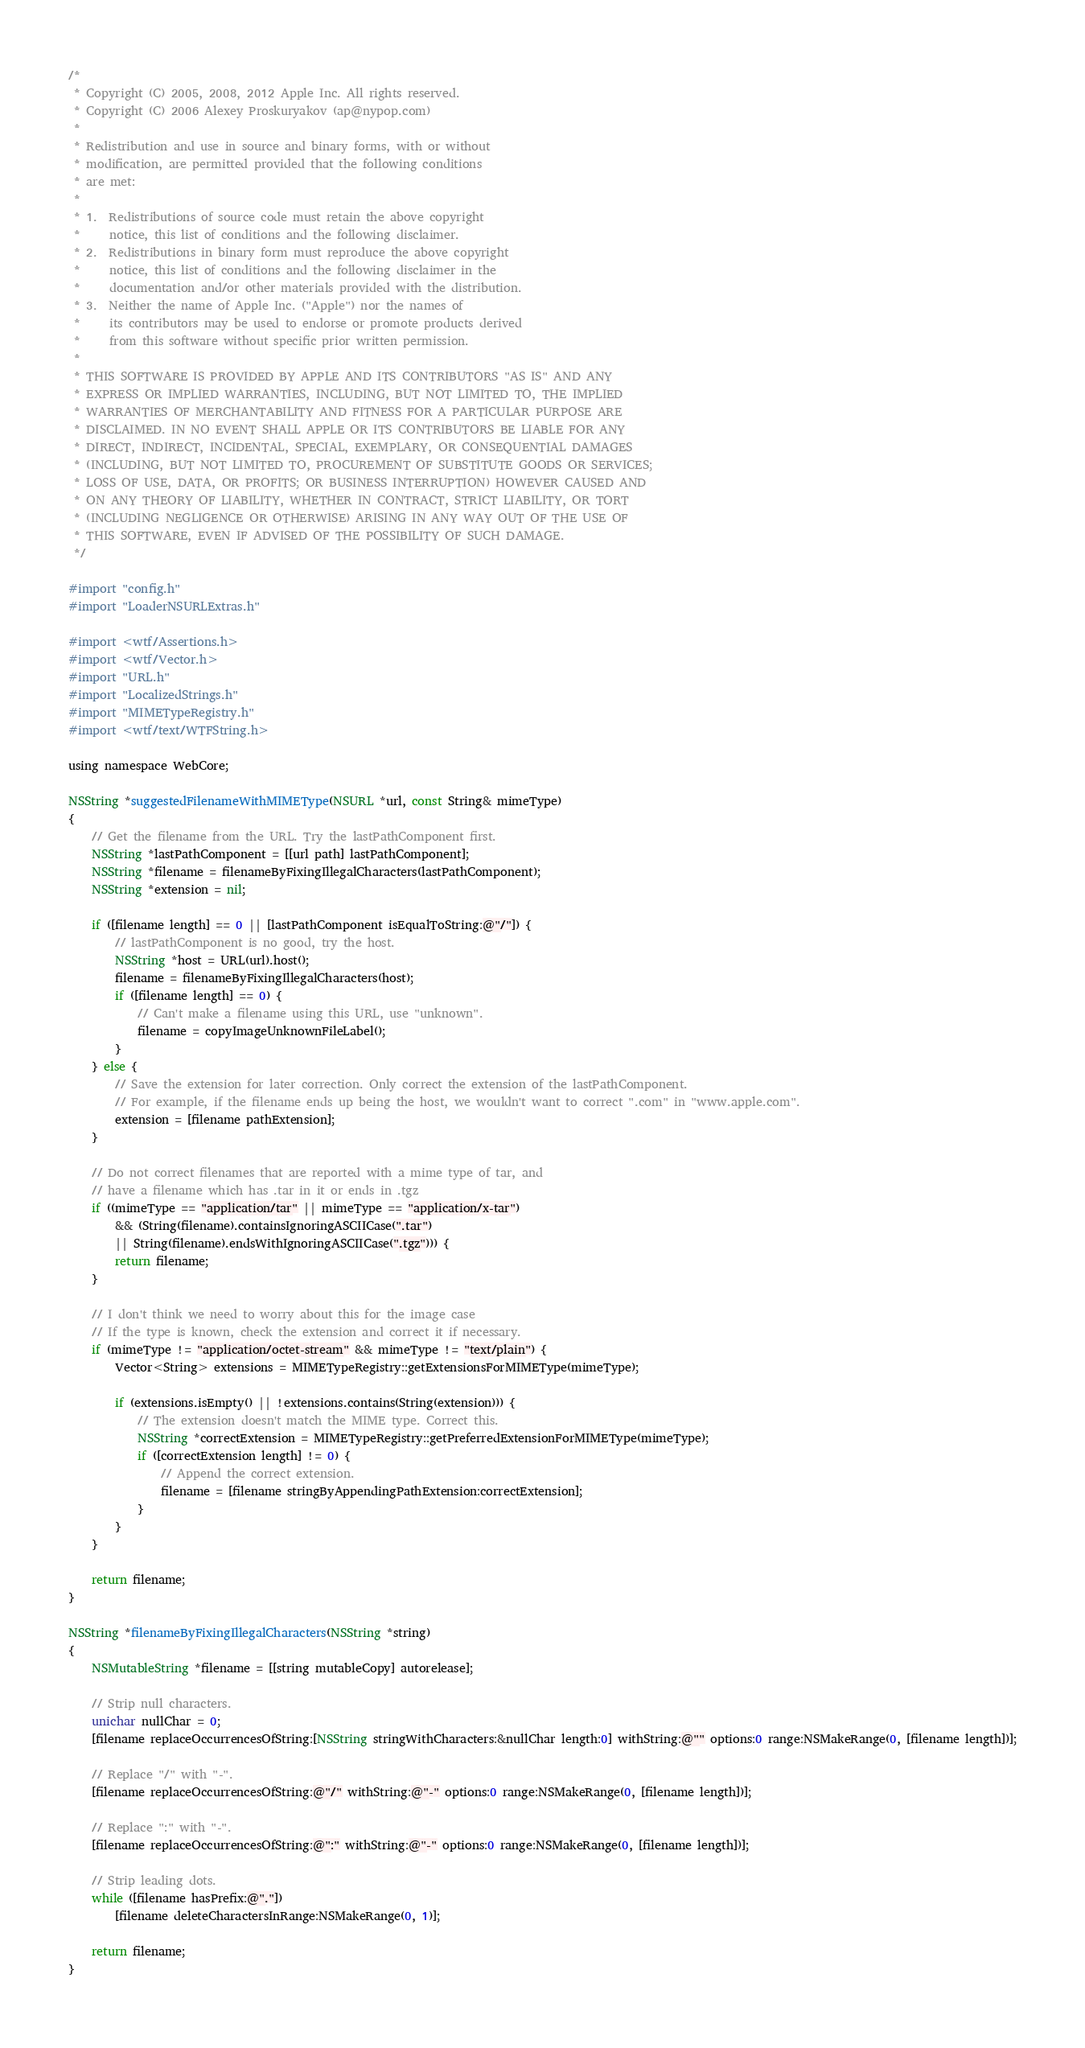Convert code to text. <code><loc_0><loc_0><loc_500><loc_500><_ObjectiveC_>/*
 * Copyright (C) 2005, 2008, 2012 Apple Inc. All rights reserved.
 * Copyright (C) 2006 Alexey Proskuryakov (ap@nypop.com)
 *
 * Redistribution and use in source and binary forms, with or without
 * modification, are permitted provided that the following conditions
 * are met:
 *
 * 1.  Redistributions of source code must retain the above copyright
 *     notice, this list of conditions and the following disclaimer. 
 * 2.  Redistributions in binary form must reproduce the above copyright
 *     notice, this list of conditions and the following disclaimer in the
 *     documentation and/or other materials provided with the distribution. 
 * 3.  Neither the name of Apple Inc. ("Apple") nor the names of
 *     its contributors may be used to endorse or promote products derived
 *     from this software without specific prior written permission. 
 *
 * THIS SOFTWARE IS PROVIDED BY APPLE AND ITS CONTRIBUTORS "AS IS" AND ANY
 * EXPRESS OR IMPLIED WARRANTIES, INCLUDING, BUT NOT LIMITED TO, THE IMPLIED
 * WARRANTIES OF MERCHANTABILITY AND FITNESS FOR A PARTICULAR PURPOSE ARE
 * DISCLAIMED. IN NO EVENT SHALL APPLE OR ITS CONTRIBUTORS BE LIABLE FOR ANY
 * DIRECT, INDIRECT, INCIDENTAL, SPECIAL, EXEMPLARY, OR CONSEQUENTIAL DAMAGES
 * (INCLUDING, BUT NOT LIMITED TO, PROCUREMENT OF SUBSTITUTE GOODS OR SERVICES;
 * LOSS OF USE, DATA, OR PROFITS; OR BUSINESS INTERRUPTION) HOWEVER CAUSED AND
 * ON ANY THEORY OF LIABILITY, WHETHER IN CONTRACT, STRICT LIABILITY, OR TORT
 * (INCLUDING NEGLIGENCE OR OTHERWISE) ARISING IN ANY WAY OUT OF THE USE OF
 * THIS SOFTWARE, EVEN IF ADVISED OF THE POSSIBILITY OF SUCH DAMAGE.
 */

#import "config.h"
#import "LoaderNSURLExtras.h"

#import <wtf/Assertions.h>
#import <wtf/Vector.h>
#import "URL.h"
#import "LocalizedStrings.h"
#import "MIMETypeRegistry.h"
#import <wtf/text/WTFString.h>

using namespace WebCore;

NSString *suggestedFilenameWithMIMEType(NSURL *url, const String& mimeType)
{
    // Get the filename from the URL. Try the lastPathComponent first.
    NSString *lastPathComponent = [[url path] lastPathComponent];
    NSString *filename = filenameByFixingIllegalCharacters(lastPathComponent);
    NSString *extension = nil;

    if ([filename length] == 0 || [lastPathComponent isEqualToString:@"/"]) {
        // lastPathComponent is no good, try the host.
        NSString *host = URL(url).host();
        filename = filenameByFixingIllegalCharacters(host);
        if ([filename length] == 0) {
            // Can't make a filename using this URL, use "unknown".
            filename = copyImageUnknownFileLabel();
        }
    } else {
        // Save the extension for later correction. Only correct the extension of the lastPathComponent.
        // For example, if the filename ends up being the host, we wouldn't want to correct ".com" in "www.apple.com".
        extension = [filename pathExtension];
    }

    // Do not correct filenames that are reported with a mime type of tar, and 
    // have a filename which has .tar in it or ends in .tgz
    if ((mimeType == "application/tar" || mimeType == "application/x-tar")
        && (String(filename).containsIgnoringASCIICase(".tar")
        || String(filename).endsWithIgnoringASCIICase(".tgz"))) {
        return filename;
    }

    // I don't think we need to worry about this for the image case
    // If the type is known, check the extension and correct it if necessary.
    if (mimeType != "application/octet-stream" && mimeType != "text/plain") {
        Vector<String> extensions = MIMETypeRegistry::getExtensionsForMIMEType(mimeType);

        if (extensions.isEmpty() || !extensions.contains(String(extension))) {
            // The extension doesn't match the MIME type. Correct this.
            NSString *correctExtension = MIMETypeRegistry::getPreferredExtensionForMIMEType(mimeType);
            if ([correctExtension length] != 0) {
                // Append the correct extension.
                filename = [filename stringByAppendingPathExtension:correctExtension];
            }
        }
    }

    return filename;
}

NSString *filenameByFixingIllegalCharacters(NSString *string)
{
    NSMutableString *filename = [[string mutableCopy] autorelease];

    // Strip null characters.
    unichar nullChar = 0;
    [filename replaceOccurrencesOfString:[NSString stringWithCharacters:&nullChar length:0] withString:@"" options:0 range:NSMakeRange(0, [filename length])];

    // Replace "/" with "-".
    [filename replaceOccurrencesOfString:@"/" withString:@"-" options:0 range:NSMakeRange(0, [filename length])];

    // Replace ":" with "-".
    [filename replaceOccurrencesOfString:@":" withString:@"-" options:0 range:NSMakeRange(0, [filename length])];

    // Strip leading dots.
    while ([filename hasPrefix:@"."])
        [filename deleteCharactersInRange:NSMakeRange(0, 1)];

    return filename;
}
</code> 